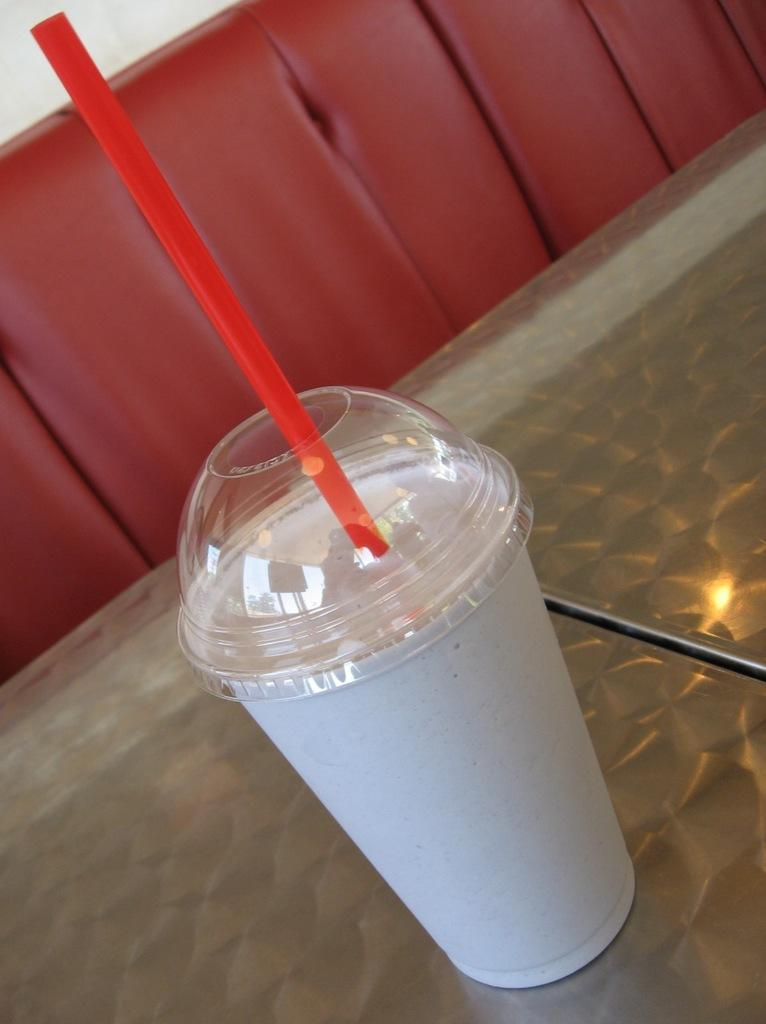What type of glass is visible in the image? There is a white color glass in the image. What is the color of the straw in the image? The straw in the image is red color. Where is the red color straw placed? The red color straw is kept on a table. What type of furniture is present in the image? There is a red color sofa in the image. Where is the red color sofa located in relation to the table? The red color sofa is behind the table. What type of jeans is visible on the red color sofa in the image? There are no jeans present in the image; it only features a white color glass, a red color straw, a table, and a red color sofa. 